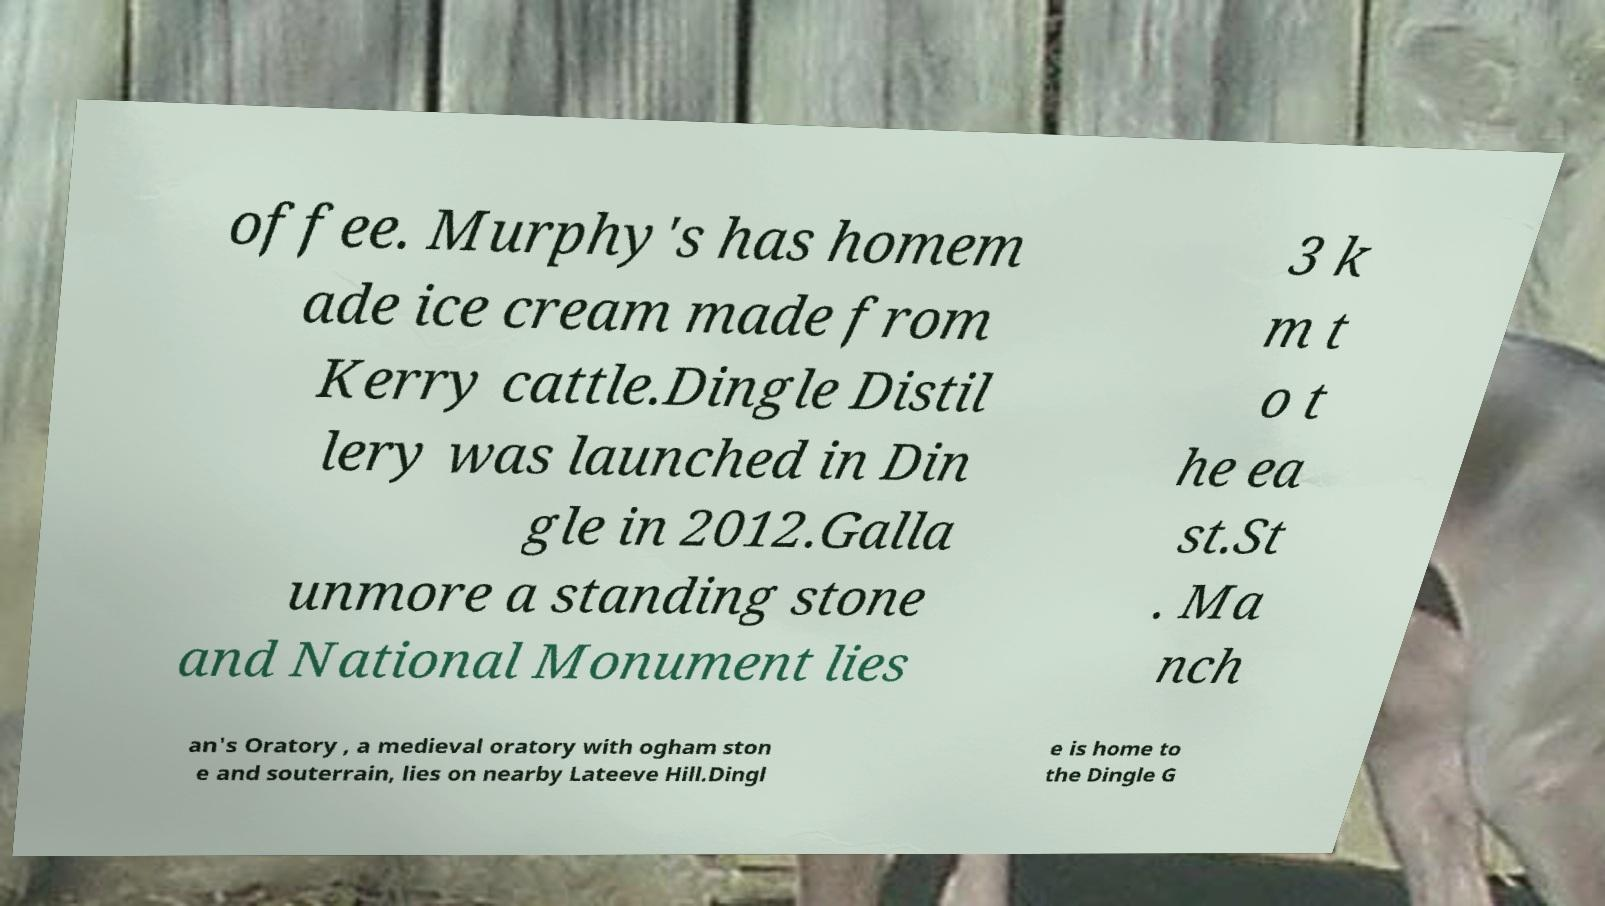Can you accurately transcribe the text from the provided image for me? offee. Murphy's has homem ade ice cream made from Kerry cattle.Dingle Distil lery was launched in Din gle in 2012.Galla unmore a standing stone and National Monument lies 3 k m t o t he ea st.St . Ma nch an's Oratory , a medieval oratory with ogham ston e and souterrain, lies on nearby Lateeve Hill.Dingl e is home to the Dingle G 